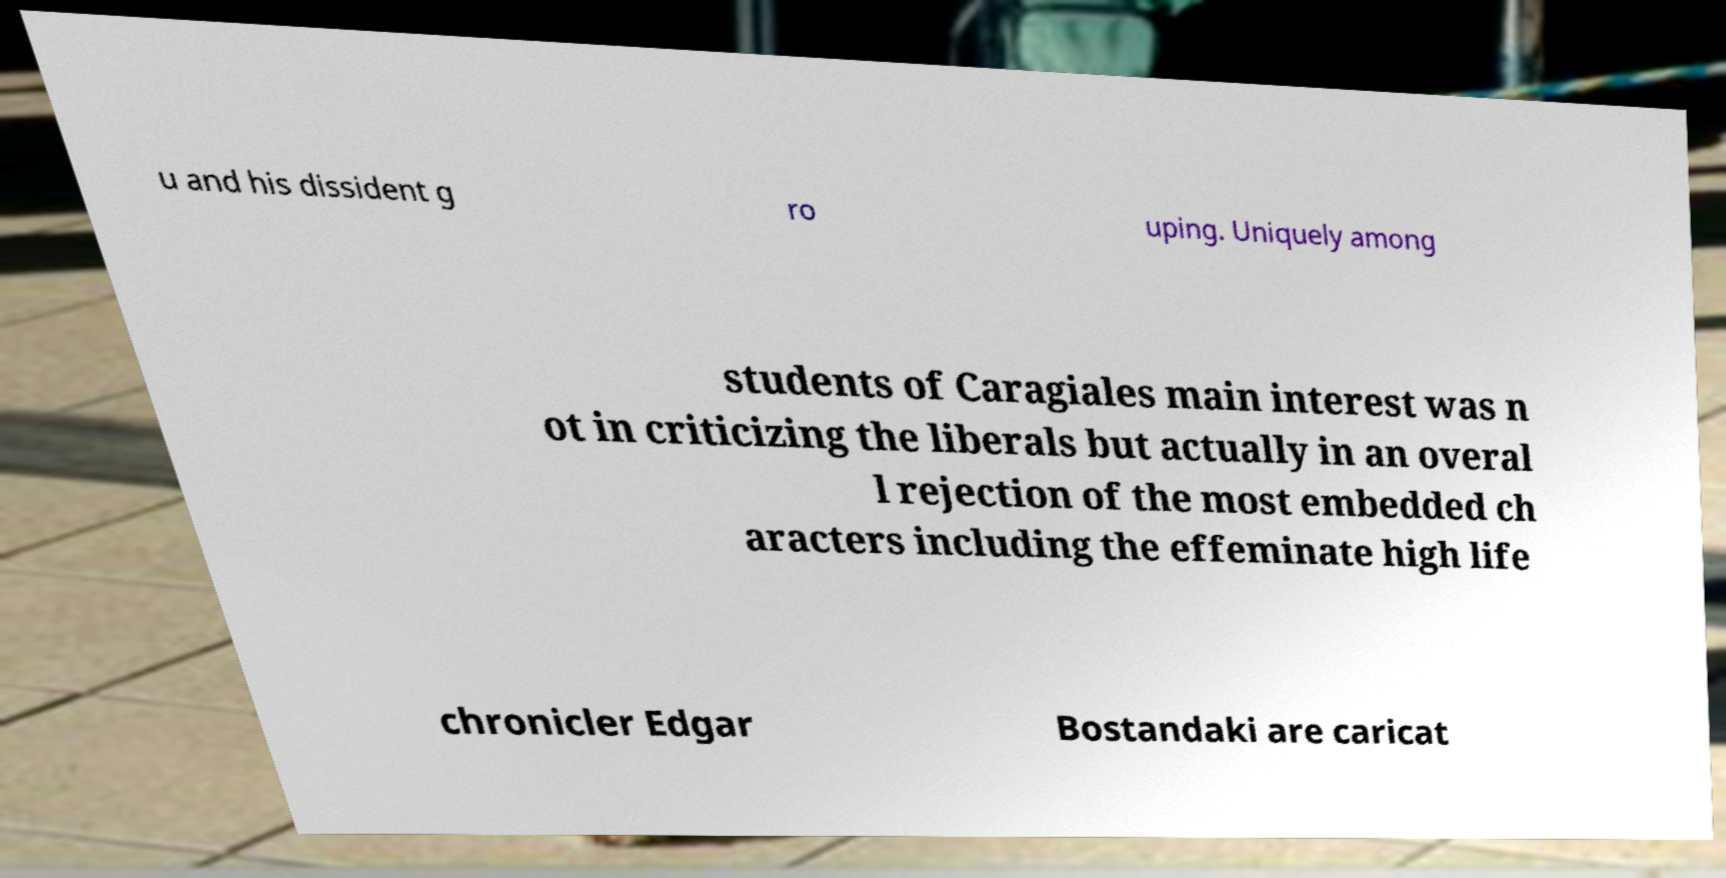Please identify and transcribe the text found in this image. u and his dissident g ro uping. Uniquely among students of Caragiales main interest was n ot in criticizing the liberals but actually in an overal l rejection of the most embedded ch aracters including the effeminate high life chronicler Edgar Bostandaki are caricat 